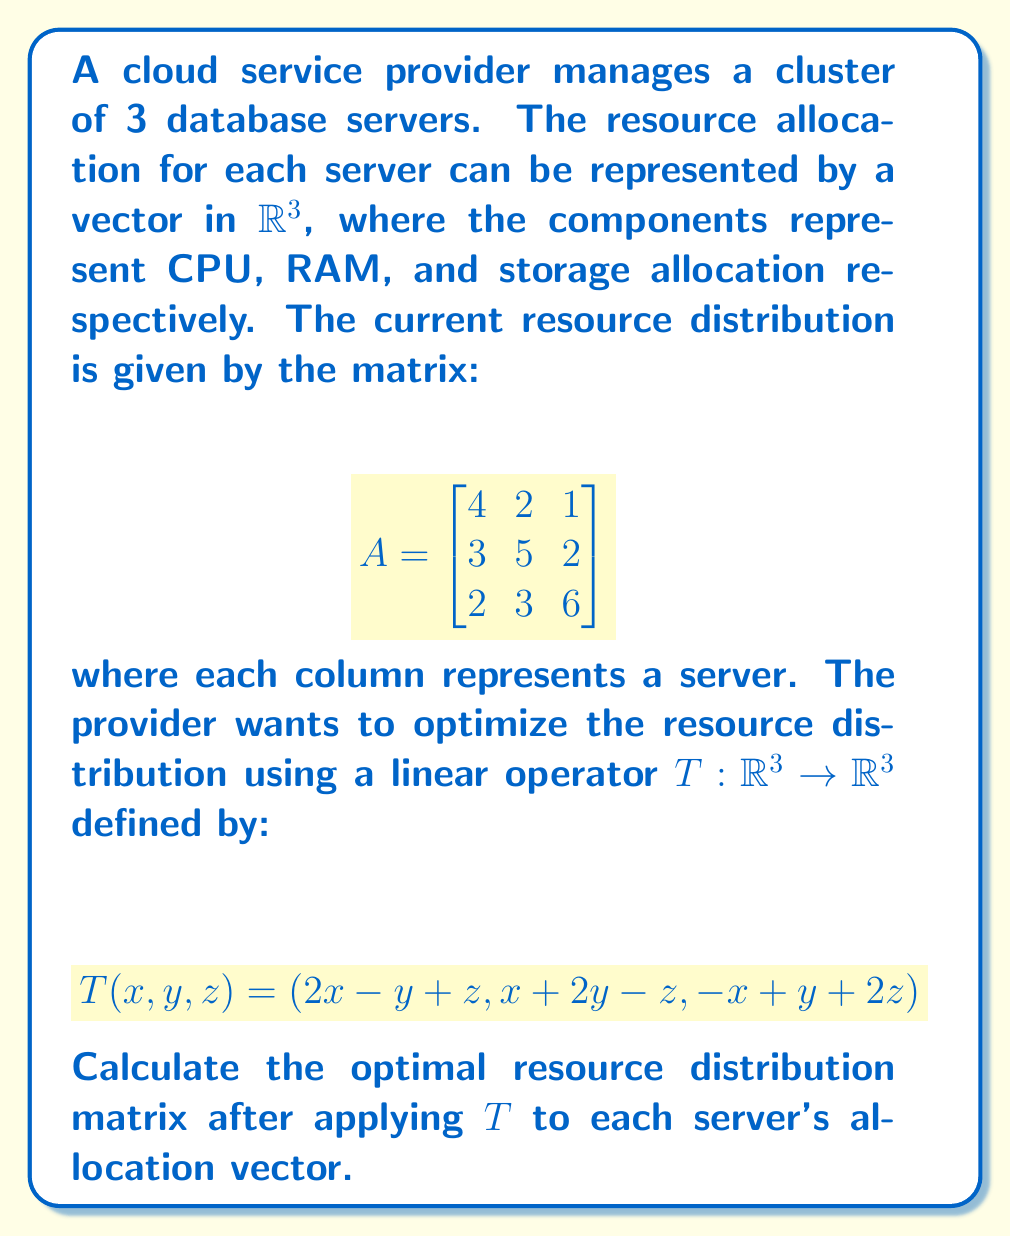Show me your answer to this math problem. To solve this problem, we need to apply the linear operator $T$ to each column of the given matrix $A$. Let's break it down step-by-step:

1) First, let's recall the definition of $T$:
   $T(x, y, z) = (2x - y + z, x + 2y - z, -x + y + 2z)$

2) Now, let's apply $T$ to each column of $A$:

   For the first column $(4, 3, 2)$:
   $T(4, 3, 2) = (2(4) - 3 + 2, 4 + 2(3) - 2, -4 + 3 + 2(2))$
                $= (7, 8, 3)$

   For the second column $(2, 5, 3)$:
   $T(2, 5, 3) = (2(2) - 5 + 3, 2 + 2(5) - 3, -2 + 5 + 2(3))$
                $= (2, 9, 9)$

   For the third column $(1, 2, 6)$:
   $T(1, 2, 6) = (2(1) - 2 + 6, 1 + 2(2) - 6, -1 + 2 + 2(6))$
                $= (6, -1, 13)$

3) Now we can construct the new matrix by combining these resultant vectors:

   $$T(A) = \begin{bmatrix}
   7 & 2 & 6 \\
   8 & 9 & -1 \\
   3 & 9 & 13
   \end{bmatrix}$$

This matrix represents the optimal resource distribution after applying the linear operator $T$.
Answer: $$\begin{bmatrix}
7 & 2 & 6 \\
8 & 9 & -1 \\
3 & 9 & 13
\end{bmatrix}$$ 